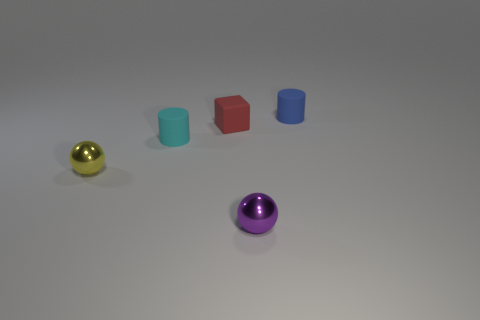There is a thing that is to the left of the cyan matte cylinder; what shape is it?
Keep it short and to the point. Sphere. There is a small object in front of the yellow metallic ball; does it have the same shape as the tiny yellow metal thing?
Your answer should be very brief. Yes. What number of objects are either tiny balls that are to the right of the yellow sphere or red blocks?
Provide a short and direct response. 2. What is the color of the other thing that is the same shape as the cyan rubber thing?
Make the answer very short. Blue. Are there any other things that are the same color as the small matte cube?
Make the answer very short. No. What is the size of the shiny object to the right of the tiny yellow ball?
Make the answer very short. Small. How many other objects are there of the same material as the blue cylinder?
Your answer should be compact. 2. Is the number of tiny blue rubber cylinders greater than the number of rubber objects?
Offer a terse response. No. There is a small shiny object right of the tiny cyan cylinder; does it have the same color as the cube?
Provide a short and direct response. No. What is the color of the tiny cube?
Give a very brief answer. Red. 